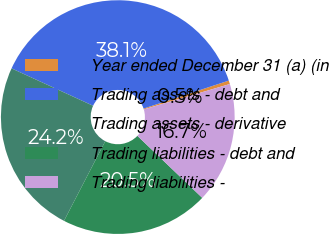Convert chart. <chart><loc_0><loc_0><loc_500><loc_500><pie_chart><fcel>Year ended December 31 (a) (in<fcel>Trading assets - debt and<fcel>Trading assets - derivative<fcel>Trading liabilities - debt and<fcel>Trading liabilities -<nl><fcel>0.49%<fcel>38.1%<fcel>24.23%<fcel>20.47%<fcel>16.71%<nl></chart> 